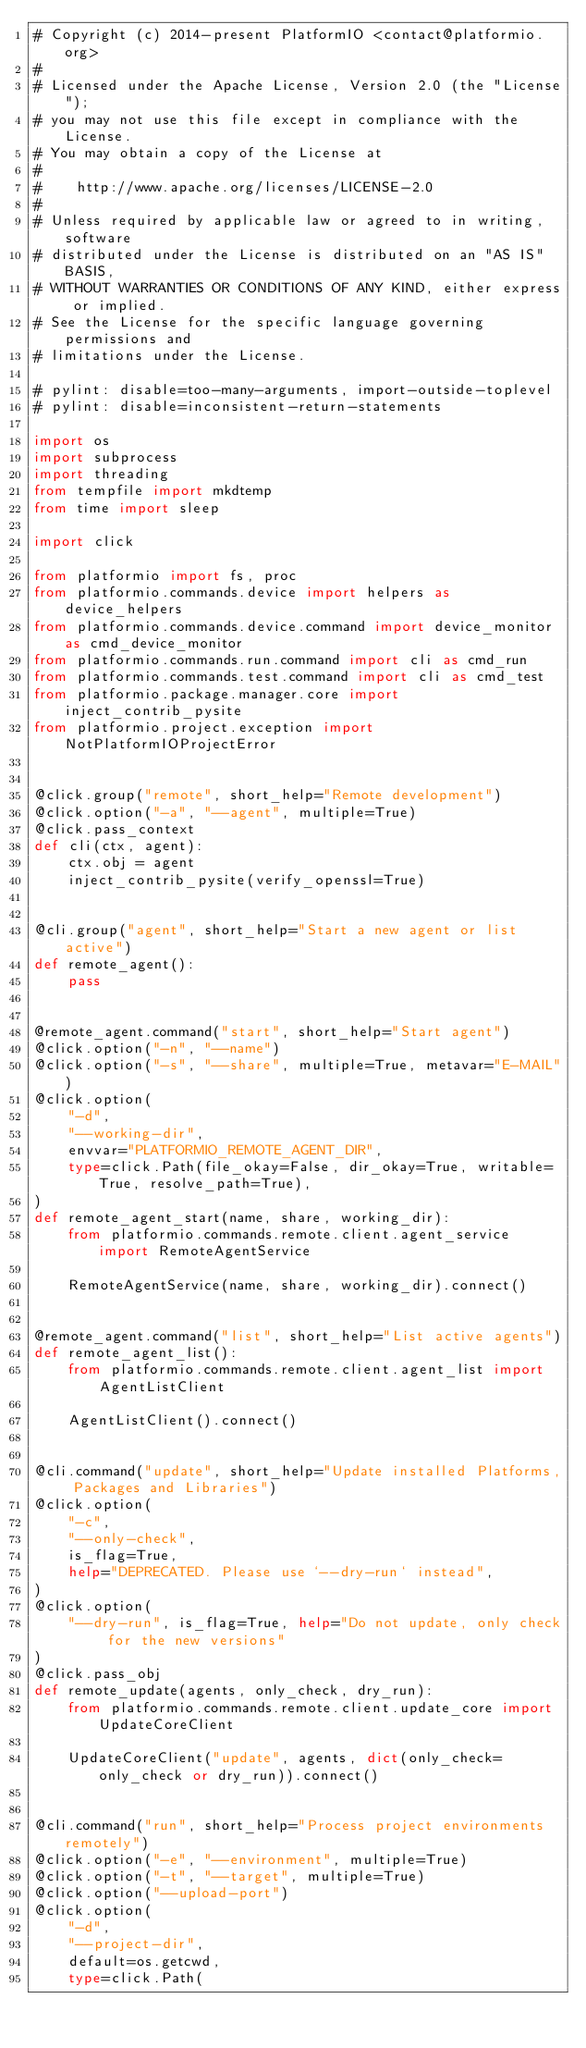Convert code to text. <code><loc_0><loc_0><loc_500><loc_500><_Python_># Copyright (c) 2014-present PlatformIO <contact@platformio.org>
#
# Licensed under the Apache License, Version 2.0 (the "License");
# you may not use this file except in compliance with the License.
# You may obtain a copy of the License at
#
#    http://www.apache.org/licenses/LICENSE-2.0
#
# Unless required by applicable law or agreed to in writing, software
# distributed under the License is distributed on an "AS IS" BASIS,
# WITHOUT WARRANTIES OR CONDITIONS OF ANY KIND, either express or implied.
# See the License for the specific language governing permissions and
# limitations under the License.

# pylint: disable=too-many-arguments, import-outside-toplevel
# pylint: disable=inconsistent-return-statements

import os
import subprocess
import threading
from tempfile import mkdtemp
from time import sleep

import click

from platformio import fs, proc
from platformio.commands.device import helpers as device_helpers
from platformio.commands.device.command import device_monitor as cmd_device_monitor
from platformio.commands.run.command import cli as cmd_run
from platformio.commands.test.command import cli as cmd_test
from platformio.package.manager.core import inject_contrib_pysite
from platformio.project.exception import NotPlatformIOProjectError


@click.group("remote", short_help="Remote development")
@click.option("-a", "--agent", multiple=True)
@click.pass_context
def cli(ctx, agent):
    ctx.obj = agent
    inject_contrib_pysite(verify_openssl=True)


@cli.group("agent", short_help="Start a new agent or list active")
def remote_agent():
    pass


@remote_agent.command("start", short_help="Start agent")
@click.option("-n", "--name")
@click.option("-s", "--share", multiple=True, metavar="E-MAIL")
@click.option(
    "-d",
    "--working-dir",
    envvar="PLATFORMIO_REMOTE_AGENT_DIR",
    type=click.Path(file_okay=False, dir_okay=True, writable=True, resolve_path=True),
)
def remote_agent_start(name, share, working_dir):
    from platformio.commands.remote.client.agent_service import RemoteAgentService

    RemoteAgentService(name, share, working_dir).connect()


@remote_agent.command("list", short_help="List active agents")
def remote_agent_list():
    from platformio.commands.remote.client.agent_list import AgentListClient

    AgentListClient().connect()


@cli.command("update", short_help="Update installed Platforms, Packages and Libraries")
@click.option(
    "-c",
    "--only-check",
    is_flag=True,
    help="DEPRECATED. Please use `--dry-run` instead",
)
@click.option(
    "--dry-run", is_flag=True, help="Do not update, only check for the new versions"
)
@click.pass_obj
def remote_update(agents, only_check, dry_run):
    from platformio.commands.remote.client.update_core import UpdateCoreClient

    UpdateCoreClient("update", agents, dict(only_check=only_check or dry_run)).connect()


@cli.command("run", short_help="Process project environments remotely")
@click.option("-e", "--environment", multiple=True)
@click.option("-t", "--target", multiple=True)
@click.option("--upload-port")
@click.option(
    "-d",
    "--project-dir",
    default=os.getcwd,
    type=click.Path(</code> 